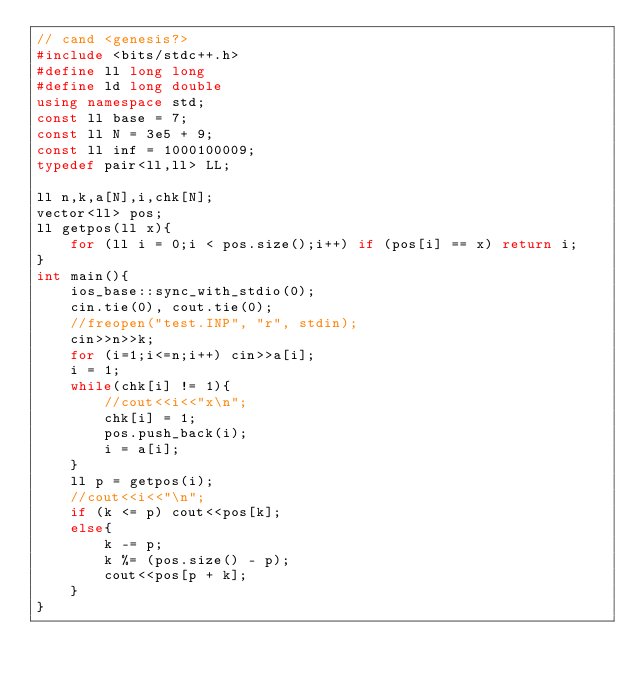Convert code to text. <code><loc_0><loc_0><loc_500><loc_500><_C++_>// cand <genesis?>
#include <bits/stdc++.h>
#define ll long long
#define ld long double
using namespace std;
const ll base = 7;
const ll N = 3e5 + 9;
const ll inf = 1000100009;
typedef pair<ll,ll> LL;

ll n,k,a[N],i,chk[N];
vector<ll> pos;
ll getpos(ll x){
    for (ll i = 0;i < pos.size();i++) if (pos[i] == x) return i;
}
int main(){
    ios_base::sync_with_stdio(0);
    cin.tie(0), cout.tie(0);
    //freopen("test.INP", "r", stdin);
    cin>>n>>k;
    for (i=1;i<=n;i++) cin>>a[i];
    i = 1;
    while(chk[i] != 1){
        //cout<<i<<"x\n";
        chk[i] = 1;
        pos.push_back(i);
        i = a[i];
    }
    ll p = getpos(i);
    //cout<<i<<"\n";
    if (k <= p) cout<<pos[k];
    else{
        k -= p;
        k %= (pos.size() - p);
        cout<<pos[p + k];
    }
}
</code> 